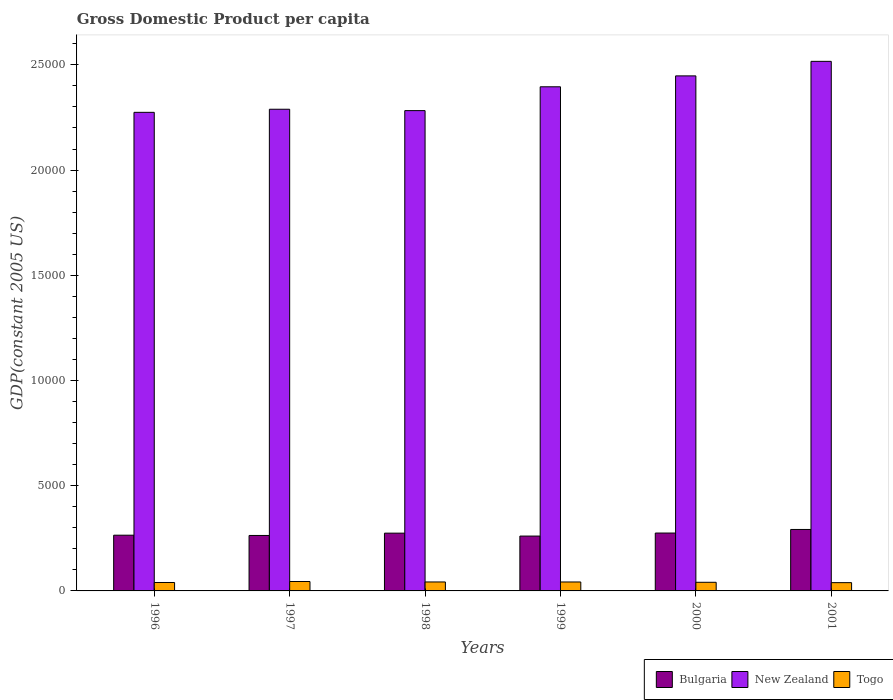How many different coloured bars are there?
Offer a very short reply. 3. How many groups of bars are there?
Give a very brief answer. 6. What is the label of the 3rd group of bars from the left?
Your answer should be compact. 1998. What is the GDP per capita in New Zealand in 1997?
Ensure brevity in your answer.  2.29e+04. Across all years, what is the maximum GDP per capita in New Zealand?
Offer a very short reply. 2.52e+04. Across all years, what is the minimum GDP per capita in New Zealand?
Ensure brevity in your answer.  2.27e+04. What is the total GDP per capita in Bulgaria in the graph?
Ensure brevity in your answer.  1.63e+04. What is the difference between the GDP per capita in Togo in 1996 and that in 2000?
Ensure brevity in your answer.  -9.59. What is the difference between the GDP per capita in Bulgaria in 1998 and the GDP per capita in Togo in 2001?
Make the answer very short. 2352.67. What is the average GDP per capita in Togo per year?
Your response must be concise. 417.01. In the year 2000, what is the difference between the GDP per capita in New Zealand and GDP per capita in Bulgaria?
Provide a short and direct response. 2.17e+04. What is the ratio of the GDP per capita in New Zealand in 1996 to that in 1999?
Offer a terse response. 0.95. Is the GDP per capita in New Zealand in 1998 less than that in 2001?
Provide a succinct answer. Yes. Is the difference between the GDP per capita in New Zealand in 1997 and 2000 greater than the difference between the GDP per capita in Bulgaria in 1997 and 2000?
Ensure brevity in your answer.  No. What is the difference between the highest and the second highest GDP per capita in Bulgaria?
Make the answer very short. 170.43. What is the difference between the highest and the lowest GDP per capita in Togo?
Provide a succinct answer. 53.78. What does the 1st bar from the right in 2001 represents?
Keep it short and to the point. Togo. How many years are there in the graph?
Make the answer very short. 6. Are the values on the major ticks of Y-axis written in scientific E-notation?
Your response must be concise. No. Does the graph contain any zero values?
Provide a short and direct response. No. Does the graph contain grids?
Give a very brief answer. No. Where does the legend appear in the graph?
Ensure brevity in your answer.  Bottom right. How many legend labels are there?
Offer a terse response. 3. How are the legend labels stacked?
Your response must be concise. Horizontal. What is the title of the graph?
Your answer should be compact. Gross Domestic Product per capita. Does "Burundi" appear as one of the legend labels in the graph?
Offer a very short reply. No. What is the label or title of the X-axis?
Make the answer very short. Years. What is the label or title of the Y-axis?
Keep it short and to the point. GDP(constant 2005 US). What is the GDP(constant 2005 US) of Bulgaria in 1996?
Keep it short and to the point. 2648.54. What is the GDP(constant 2005 US) of New Zealand in 1996?
Offer a terse response. 2.27e+04. What is the GDP(constant 2005 US) in Togo in 1996?
Your answer should be compact. 400.93. What is the GDP(constant 2005 US) in Bulgaria in 1997?
Provide a succinct answer. 2635.4. What is the GDP(constant 2005 US) of New Zealand in 1997?
Ensure brevity in your answer.  2.29e+04. What is the GDP(constant 2005 US) of Togo in 1997?
Make the answer very short. 447.02. What is the GDP(constant 2005 US) of Bulgaria in 1998?
Your answer should be compact. 2745.9. What is the GDP(constant 2005 US) in New Zealand in 1998?
Provide a succinct answer. 2.28e+04. What is the GDP(constant 2005 US) in Togo in 1998?
Provide a succinct answer. 425.56. What is the GDP(constant 2005 US) of Bulgaria in 1999?
Ensure brevity in your answer.  2606.43. What is the GDP(constant 2005 US) of New Zealand in 1999?
Offer a terse response. 2.40e+04. What is the GDP(constant 2005 US) of Togo in 1999?
Provide a succinct answer. 424.84. What is the GDP(constant 2005 US) of Bulgaria in 2000?
Make the answer very short. 2750.59. What is the GDP(constant 2005 US) in New Zealand in 2000?
Ensure brevity in your answer.  2.45e+04. What is the GDP(constant 2005 US) of Togo in 2000?
Provide a succinct answer. 410.52. What is the GDP(constant 2005 US) of Bulgaria in 2001?
Make the answer very short. 2921.02. What is the GDP(constant 2005 US) of New Zealand in 2001?
Ensure brevity in your answer.  2.52e+04. What is the GDP(constant 2005 US) in Togo in 2001?
Make the answer very short. 393.23. Across all years, what is the maximum GDP(constant 2005 US) in Bulgaria?
Offer a very short reply. 2921.02. Across all years, what is the maximum GDP(constant 2005 US) of New Zealand?
Provide a succinct answer. 2.52e+04. Across all years, what is the maximum GDP(constant 2005 US) in Togo?
Your answer should be very brief. 447.02. Across all years, what is the minimum GDP(constant 2005 US) in Bulgaria?
Your answer should be very brief. 2606.43. Across all years, what is the minimum GDP(constant 2005 US) of New Zealand?
Offer a terse response. 2.27e+04. Across all years, what is the minimum GDP(constant 2005 US) in Togo?
Make the answer very short. 393.23. What is the total GDP(constant 2005 US) of Bulgaria in the graph?
Keep it short and to the point. 1.63e+04. What is the total GDP(constant 2005 US) of New Zealand in the graph?
Offer a very short reply. 1.42e+05. What is the total GDP(constant 2005 US) in Togo in the graph?
Your answer should be very brief. 2502.09. What is the difference between the GDP(constant 2005 US) of Bulgaria in 1996 and that in 1997?
Your response must be concise. 13.14. What is the difference between the GDP(constant 2005 US) in New Zealand in 1996 and that in 1997?
Your answer should be very brief. -147.12. What is the difference between the GDP(constant 2005 US) in Togo in 1996 and that in 1997?
Your answer should be compact. -46.09. What is the difference between the GDP(constant 2005 US) of Bulgaria in 1996 and that in 1998?
Ensure brevity in your answer.  -97.36. What is the difference between the GDP(constant 2005 US) in New Zealand in 1996 and that in 1998?
Your answer should be compact. -81.64. What is the difference between the GDP(constant 2005 US) in Togo in 1996 and that in 1998?
Your answer should be very brief. -24.63. What is the difference between the GDP(constant 2005 US) of Bulgaria in 1996 and that in 1999?
Make the answer very short. 42.11. What is the difference between the GDP(constant 2005 US) in New Zealand in 1996 and that in 1999?
Provide a short and direct response. -1214.37. What is the difference between the GDP(constant 2005 US) in Togo in 1996 and that in 1999?
Offer a terse response. -23.91. What is the difference between the GDP(constant 2005 US) of Bulgaria in 1996 and that in 2000?
Your response must be concise. -102.05. What is the difference between the GDP(constant 2005 US) of New Zealand in 1996 and that in 2000?
Your answer should be compact. -1732.25. What is the difference between the GDP(constant 2005 US) of Togo in 1996 and that in 2000?
Make the answer very short. -9.59. What is the difference between the GDP(constant 2005 US) of Bulgaria in 1996 and that in 2001?
Your answer should be very brief. -272.48. What is the difference between the GDP(constant 2005 US) in New Zealand in 1996 and that in 2001?
Your answer should be very brief. -2422.9. What is the difference between the GDP(constant 2005 US) in Togo in 1996 and that in 2001?
Your answer should be compact. 7.69. What is the difference between the GDP(constant 2005 US) of Bulgaria in 1997 and that in 1998?
Keep it short and to the point. -110.5. What is the difference between the GDP(constant 2005 US) of New Zealand in 1997 and that in 1998?
Offer a terse response. 65.48. What is the difference between the GDP(constant 2005 US) in Togo in 1997 and that in 1998?
Offer a very short reply. 21.46. What is the difference between the GDP(constant 2005 US) of Bulgaria in 1997 and that in 1999?
Ensure brevity in your answer.  28.97. What is the difference between the GDP(constant 2005 US) of New Zealand in 1997 and that in 1999?
Give a very brief answer. -1067.25. What is the difference between the GDP(constant 2005 US) of Togo in 1997 and that in 1999?
Your answer should be very brief. 22.18. What is the difference between the GDP(constant 2005 US) in Bulgaria in 1997 and that in 2000?
Keep it short and to the point. -115.19. What is the difference between the GDP(constant 2005 US) of New Zealand in 1997 and that in 2000?
Provide a succinct answer. -1585.13. What is the difference between the GDP(constant 2005 US) of Togo in 1997 and that in 2000?
Offer a very short reply. 36.5. What is the difference between the GDP(constant 2005 US) in Bulgaria in 1997 and that in 2001?
Provide a short and direct response. -285.62. What is the difference between the GDP(constant 2005 US) of New Zealand in 1997 and that in 2001?
Your response must be concise. -2275.78. What is the difference between the GDP(constant 2005 US) in Togo in 1997 and that in 2001?
Offer a very short reply. 53.78. What is the difference between the GDP(constant 2005 US) of Bulgaria in 1998 and that in 1999?
Provide a succinct answer. 139.47. What is the difference between the GDP(constant 2005 US) in New Zealand in 1998 and that in 1999?
Your answer should be compact. -1132.73. What is the difference between the GDP(constant 2005 US) of Togo in 1998 and that in 1999?
Give a very brief answer. 0.72. What is the difference between the GDP(constant 2005 US) of Bulgaria in 1998 and that in 2000?
Give a very brief answer. -4.69. What is the difference between the GDP(constant 2005 US) of New Zealand in 1998 and that in 2000?
Give a very brief answer. -1650.62. What is the difference between the GDP(constant 2005 US) in Togo in 1998 and that in 2000?
Your response must be concise. 15.04. What is the difference between the GDP(constant 2005 US) in Bulgaria in 1998 and that in 2001?
Keep it short and to the point. -175.12. What is the difference between the GDP(constant 2005 US) of New Zealand in 1998 and that in 2001?
Provide a succinct answer. -2341.26. What is the difference between the GDP(constant 2005 US) in Togo in 1998 and that in 2001?
Make the answer very short. 32.32. What is the difference between the GDP(constant 2005 US) in Bulgaria in 1999 and that in 2000?
Offer a terse response. -144.16. What is the difference between the GDP(constant 2005 US) in New Zealand in 1999 and that in 2000?
Your answer should be very brief. -517.89. What is the difference between the GDP(constant 2005 US) of Togo in 1999 and that in 2000?
Keep it short and to the point. 14.32. What is the difference between the GDP(constant 2005 US) in Bulgaria in 1999 and that in 2001?
Keep it short and to the point. -314.59. What is the difference between the GDP(constant 2005 US) of New Zealand in 1999 and that in 2001?
Provide a short and direct response. -1208.53. What is the difference between the GDP(constant 2005 US) of Togo in 1999 and that in 2001?
Give a very brief answer. 31.6. What is the difference between the GDP(constant 2005 US) in Bulgaria in 2000 and that in 2001?
Your answer should be very brief. -170.43. What is the difference between the GDP(constant 2005 US) of New Zealand in 2000 and that in 2001?
Your answer should be compact. -690.64. What is the difference between the GDP(constant 2005 US) of Togo in 2000 and that in 2001?
Provide a succinct answer. 17.29. What is the difference between the GDP(constant 2005 US) of Bulgaria in 1996 and the GDP(constant 2005 US) of New Zealand in 1997?
Ensure brevity in your answer.  -2.02e+04. What is the difference between the GDP(constant 2005 US) of Bulgaria in 1996 and the GDP(constant 2005 US) of Togo in 1997?
Your answer should be very brief. 2201.52. What is the difference between the GDP(constant 2005 US) in New Zealand in 1996 and the GDP(constant 2005 US) in Togo in 1997?
Provide a succinct answer. 2.23e+04. What is the difference between the GDP(constant 2005 US) of Bulgaria in 1996 and the GDP(constant 2005 US) of New Zealand in 1998?
Offer a very short reply. -2.02e+04. What is the difference between the GDP(constant 2005 US) of Bulgaria in 1996 and the GDP(constant 2005 US) of Togo in 1998?
Provide a short and direct response. 2222.98. What is the difference between the GDP(constant 2005 US) in New Zealand in 1996 and the GDP(constant 2005 US) in Togo in 1998?
Offer a very short reply. 2.23e+04. What is the difference between the GDP(constant 2005 US) in Bulgaria in 1996 and the GDP(constant 2005 US) in New Zealand in 1999?
Ensure brevity in your answer.  -2.13e+04. What is the difference between the GDP(constant 2005 US) in Bulgaria in 1996 and the GDP(constant 2005 US) in Togo in 1999?
Your answer should be compact. 2223.7. What is the difference between the GDP(constant 2005 US) of New Zealand in 1996 and the GDP(constant 2005 US) of Togo in 1999?
Provide a short and direct response. 2.23e+04. What is the difference between the GDP(constant 2005 US) in Bulgaria in 1996 and the GDP(constant 2005 US) in New Zealand in 2000?
Keep it short and to the point. -2.18e+04. What is the difference between the GDP(constant 2005 US) in Bulgaria in 1996 and the GDP(constant 2005 US) in Togo in 2000?
Keep it short and to the point. 2238.02. What is the difference between the GDP(constant 2005 US) in New Zealand in 1996 and the GDP(constant 2005 US) in Togo in 2000?
Give a very brief answer. 2.23e+04. What is the difference between the GDP(constant 2005 US) of Bulgaria in 1996 and the GDP(constant 2005 US) of New Zealand in 2001?
Offer a terse response. -2.25e+04. What is the difference between the GDP(constant 2005 US) in Bulgaria in 1996 and the GDP(constant 2005 US) in Togo in 2001?
Your response must be concise. 2255.3. What is the difference between the GDP(constant 2005 US) in New Zealand in 1996 and the GDP(constant 2005 US) in Togo in 2001?
Offer a very short reply. 2.24e+04. What is the difference between the GDP(constant 2005 US) in Bulgaria in 1997 and the GDP(constant 2005 US) in New Zealand in 1998?
Ensure brevity in your answer.  -2.02e+04. What is the difference between the GDP(constant 2005 US) of Bulgaria in 1997 and the GDP(constant 2005 US) of Togo in 1998?
Keep it short and to the point. 2209.84. What is the difference between the GDP(constant 2005 US) of New Zealand in 1997 and the GDP(constant 2005 US) of Togo in 1998?
Your answer should be very brief. 2.25e+04. What is the difference between the GDP(constant 2005 US) in Bulgaria in 1997 and the GDP(constant 2005 US) in New Zealand in 1999?
Offer a terse response. -2.13e+04. What is the difference between the GDP(constant 2005 US) in Bulgaria in 1997 and the GDP(constant 2005 US) in Togo in 1999?
Offer a very short reply. 2210.56. What is the difference between the GDP(constant 2005 US) of New Zealand in 1997 and the GDP(constant 2005 US) of Togo in 1999?
Your response must be concise. 2.25e+04. What is the difference between the GDP(constant 2005 US) in Bulgaria in 1997 and the GDP(constant 2005 US) in New Zealand in 2000?
Provide a short and direct response. -2.18e+04. What is the difference between the GDP(constant 2005 US) of Bulgaria in 1997 and the GDP(constant 2005 US) of Togo in 2000?
Offer a terse response. 2224.88. What is the difference between the GDP(constant 2005 US) in New Zealand in 1997 and the GDP(constant 2005 US) in Togo in 2000?
Provide a succinct answer. 2.25e+04. What is the difference between the GDP(constant 2005 US) in Bulgaria in 1997 and the GDP(constant 2005 US) in New Zealand in 2001?
Keep it short and to the point. -2.25e+04. What is the difference between the GDP(constant 2005 US) of Bulgaria in 1997 and the GDP(constant 2005 US) of Togo in 2001?
Your answer should be compact. 2242.17. What is the difference between the GDP(constant 2005 US) in New Zealand in 1997 and the GDP(constant 2005 US) in Togo in 2001?
Offer a very short reply. 2.25e+04. What is the difference between the GDP(constant 2005 US) in Bulgaria in 1998 and the GDP(constant 2005 US) in New Zealand in 1999?
Offer a terse response. -2.12e+04. What is the difference between the GDP(constant 2005 US) of Bulgaria in 1998 and the GDP(constant 2005 US) of Togo in 1999?
Offer a terse response. 2321.07. What is the difference between the GDP(constant 2005 US) in New Zealand in 1998 and the GDP(constant 2005 US) in Togo in 1999?
Offer a very short reply. 2.24e+04. What is the difference between the GDP(constant 2005 US) of Bulgaria in 1998 and the GDP(constant 2005 US) of New Zealand in 2000?
Keep it short and to the point. -2.17e+04. What is the difference between the GDP(constant 2005 US) of Bulgaria in 1998 and the GDP(constant 2005 US) of Togo in 2000?
Ensure brevity in your answer.  2335.38. What is the difference between the GDP(constant 2005 US) of New Zealand in 1998 and the GDP(constant 2005 US) of Togo in 2000?
Offer a terse response. 2.24e+04. What is the difference between the GDP(constant 2005 US) of Bulgaria in 1998 and the GDP(constant 2005 US) of New Zealand in 2001?
Offer a terse response. -2.24e+04. What is the difference between the GDP(constant 2005 US) in Bulgaria in 1998 and the GDP(constant 2005 US) in Togo in 2001?
Make the answer very short. 2352.67. What is the difference between the GDP(constant 2005 US) in New Zealand in 1998 and the GDP(constant 2005 US) in Togo in 2001?
Provide a succinct answer. 2.24e+04. What is the difference between the GDP(constant 2005 US) of Bulgaria in 1999 and the GDP(constant 2005 US) of New Zealand in 2000?
Your answer should be very brief. -2.19e+04. What is the difference between the GDP(constant 2005 US) of Bulgaria in 1999 and the GDP(constant 2005 US) of Togo in 2000?
Give a very brief answer. 2195.91. What is the difference between the GDP(constant 2005 US) of New Zealand in 1999 and the GDP(constant 2005 US) of Togo in 2000?
Keep it short and to the point. 2.35e+04. What is the difference between the GDP(constant 2005 US) in Bulgaria in 1999 and the GDP(constant 2005 US) in New Zealand in 2001?
Your answer should be compact. -2.26e+04. What is the difference between the GDP(constant 2005 US) of Bulgaria in 1999 and the GDP(constant 2005 US) of Togo in 2001?
Provide a succinct answer. 2213.19. What is the difference between the GDP(constant 2005 US) in New Zealand in 1999 and the GDP(constant 2005 US) in Togo in 2001?
Provide a succinct answer. 2.36e+04. What is the difference between the GDP(constant 2005 US) of Bulgaria in 2000 and the GDP(constant 2005 US) of New Zealand in 2001?
Ensure brevity in your answer.  -2.24e+04. What is the difference between the GDP(constant 2005 US) in Bulgaria in 2000 and the GDP(constant 2005 US) in Togo in 2001?
Provide a succinct answer. 2357.35. What is the difference between the GDP(constant 2005 US) in New Zealand in 2000 and the GDP(constant 2005 US) in Togo in 2001?
Your answer should be compact. 2.41e+04. What is the average GDP(constant 2005 US) of Bulgaria per year?
Your answer should be very brief. 2717.98. What is the average GDP(constant 2005 US) of New Zealand per year?
Your answer should be compact. 2.37e+04. What is the average GDP(constant 2005 US) of Togo per year?
Offer a very short reply. 417.01. In the year 1996, what is the difference between the GDP(constant 2005 US) in Bulgaria and GDP(constant 2005 US) in New Zealand?
Provide a succinct answer. -2.01e+04. In the year 1996, what is the difference between the GDP(constant 2005 US) in Bulgaria and GDP(constant 2005 US) in Togo?
Your answer should be compact. 2247.61. In the year 1996, what is the difference between the GDP(constant 2005 US) in New Zealand and GDP(constant 2005 US) in Togo?
Offer a terse response. 2.23e+04. In the year 1997, what is the difference between the GDP(constant 2005 US) of Bulgaria and GDP(constant 2005 US) of New Zealand?
Provide a short and direct response. -2.03e+04. In the year 1997, what is the difference between the GDP(constant 2005 US) of Bulgaria and GDP(constant 2005 US) of Togo?
Your response must be concise. 2188.38. In the year 1997, what is the difference between the GDP(constant 2005 US) in New Zealand and GDP(constant 2005 US) in Togo?
Ensure brevity in your answer.  2.24e+04. In the year 1998, what is the difference between the GDP(constant 2005 US) of Bulgaria and GDP(constant 2005 US) of New Zealand?
Offer a terse response. -2.01e+04. In the year 1998, what is the difference between the GDP(constant 2005 US) in Bulgaria and GDP(constant 2005 US) in Togo?
Your answer should be very brief. 2320.34. In the year 1998, what is the difference between the GDP(constant 2005 US) of New Zealand and GDP(constant 2005 US) of Togo?
Your answer should be very brief. 2.24e+04. In the year 1999, what is the difference between the GDP(constant 2005 US) of Bulgaria and GDP(constant 2005 US) of New Zealand?
Your answer should be compact. -2.14e+04. In the year 1999, what is the difference between the GDP(constant 2005 US) of Bulgaria and GDP(constant 2005 US) of Togo?
Offer a very short reply. 2181.59. In the year 1999, what is the difference between the GDP(constant 2005 US) of New Zealand and GDP(constant 2005 US) of Togo?
Your response must be concise. 2.35e+04. In the year 2000, what is the difference between the GDP(constant 2005 US) of Bulgaria and GDP(constant 2005 US) of New Zealand?
Provide a short and direct response. -2.17e+04. In the year 2000, what is the difference between the GDP(constant 2005 US) in Bulgaria and GDP(constant 2005 US) in Togo?
Give a very brief answer. 2340.07. In the year 2000, what is the difference between the GDP(constant 2005 US) in New Zealand and GDP(constant 2005 US) in Togo?
Keep it short and to the point. 2.41e+04. In the year 2001, what is the difference between the GDP(constant 2005 US) of Bulgaria and GDP(constant 2005 US) of New Zealand?
Offer a terse response. -2.22e+04. In the year 2001, what is the difference between the GDP(constant 2005 US) of Bulgaria and GDP(constant 2005 US) of Togo?
Provide a succinct answer. 2527.79. In the year 2001, what is the difference between the GDP(constant 2005 US) in New Zealand and GDP(constant 2005 US) in Togo?
Your response must be concise. 2.48e+04. What is the ratio of the GDP(constant 2005 US) of Togo in 1996 to that in 1997?
Your response must be concise. 0.9. What is the ratio of the GDP(constant 2005 US) of Bulgaria in 1996 to that in 1998?
Offer a very short reply. 0.96. What is the ratio of the GDP(constant 2005 US) in New Zealand in 1996 to that in 1998?
Offer a terse response. 1. What is the ratio of the GDP(constant 2005 US) of Togo in 1996 to that in 1998?
Offer a very short reply. 0.94. What is the ratio of the GDP(constant 2005 US) in Bulgaria in 1996 to that in 1999?
Make the answer very short. 1.02. What is the ratio of the GDP(constant 2005 US) of New Zealand in 1996 to that in 1999?
Ensure brevity in your answer.  0.95. What is the ratio of the GDP(constant 2005 US) in Togo in 1996 to that in 1999?
Offer a terse response. 0.94. What is the ratio of the GDP(constant 2005 US) in Bulgaria in 1996 to that in 2000?
Your answer should be very brief. 0.96. What is the ratio of the GDP(constant 2005 US) in New Zealand in 1996 to that in 2000?
Your response must be concise. 0.93. What is the ratio of the GDP(constant 2005 US) of Togo in 1996 to that in 2000?
Make the answer very short. 0.98. What is the ratio of the GDP(constant 2005 US) in Bulgaria in 1996 to that in 2001?
Your answer should be very brief. 0.91. What is the ratio of the GDP(constant 2005 US) in New Zealand in 1996 to that in 2001?
Provide a short and direct response. 0.9. What is the ratio of the GDP(constant 2005 US) of Togo in 1996 to that in 2001?
Ensure brevity in your answer.  1.02. What is the ratio of the GDP(constant 2005 US) in Bulgaria in 1997 to that in 1998?
Provide a short and direct response. 0.96. What is the ratio of the GDP(constant 2005 US) in Togo in 1997 to that in 1998?
Your response must be concise. 1.05. What is the ratio of the GDP(constant 2005 US) in Bulgaria in 1997 to that in 1999?
Provide a succinct answer. 1.01. What is the ratio of the GDP(constant 2005 US) in New Zealand in 1997 to that in 1999?
Give a very brief answer. 0.96. What is the ratio of the GDP(constant 2005 US) in Togo in 1997 to that in 1999?
Your answer should be compact. 1.05. What is the ratio of the GDP(constant 2005 US) of Bulgaria in 1997 to that in 2000?
Your answer should be very brief. 0.96. What is the ratio of the GDP(constant 2005 US) of New Zealand in 1997 to that in 2000?
Keep it short and to the point. 0.94. What is the ratio of the GDP(constant 2005 US) in Togo in 1997 to that in 2000?
Offer a terse response. 1.09. What is the ratio of the GDP(constant 2005 US) in Bulgaria in 1997 to that in 2001?
Provide a short and direct response. 0.9. What is the ratio of the GDP(constant 2005 US) in New Zealand in 1997 to that in 2001?
Ensure brevity in your answer.  0.91. What is the ratio of the GDP(constant 2005 US) in Togo in 1997 to that in 2001?
Ensure brevity in your answer.  1.14. What is the ratio of the GDP(constant 2005 US) of Bulgaria in 1998 to that in 1999?
Give a very brief answer. 1.05. What is the ratio of the GDP(constant 2005 US) of New Zealand in 1998 to that in 1999?
Offer a very short reply. 0.95. What is the ratio of the GDP(constant 2005 US) in New Zealand in 1998 to that in 2000?
Keep it short and to the point. 0.93. What is the ratio of the GDP(constant 2005 US) of Togo in 1998 to that in 2000?
Provide a short and direct response. 1.04. What is the ratio of the GDP(constant 2005 US) in Bulgaria in 1998 to that in 2001?
Ensure brevity in your answer.  0.94. What is the ratio of the GDP(constant 2005 US) in New Zealand in 1998 to that in 2001?
Offer a terse response. 0.91. What is the ratio of the GDP(constant 2005 US) in Togo in 1998 to that in 2001?
Provide a succinct answer. 1.08. What is the ratio of the GDP(constant 2005 US) of Bulgaria in 1999 to that in 2000?
Provide a short and direct response. 0.95. What is the ratio of the GDP(constant 2005 US) of New Zealand in 1999 to that in 2000?
Keep it short and to the point. 0.98. What is the ratio of the GDP(constant 2005 US) in Togo in 1999 to that in 2000?
Your answer should be very brief. 1.03. What is the ratio of the GDP(constant 2005 US) in Bulgaria in 1999 to that in 2001?
Your answer should be compact. 0.89. What is the ratio of the GDP(constant 2005 US) in New Zealand in 1999 to that in 2001?
Provide a succinct answer. 0.95. What is the ratio of the GDP(constant 2005 US) in Togo in 1999 to that in 2001?
Your answer should be very brief. 1.08. What is the ratio of the GDP(constant 2005 US) in Bulgaria in 2000 to that in 2001?
Give a very brief answer. 0.94. What is the ratio of the GDP(constant 2005 US) in New Zealand in 2000 to that in 2001?
Keep it short and to the point. 0.97. What is the ratio of the GDP(constant 2005 US) in Togo in 2000 to that in 2001?
Make the answer very short. 1.04. What is the difference between the highest and the second highest GDP(constant 2005 US) of Bulgaria?
Offer a terse response. 170.43. What is the difference between the highest and the second highest GDP(constant 2005 US) in New Zealand?
Give a very brief answer. 690.64. What is the difference between the highest and the second highest GDP(constant 2005 US) of Togo?
Your answer should be very brief. 21.46. What is the difference between the highest and the lowest GDP(constant 2005 US) of Bulgaria?
Make the answer very short. 314.59. What is the difference between the highest and the lowest GDP(constant 2005 US) in New Zealand?
Give a very brief answer. 2422.9. What is the difference between the highest and the lowest GDP(constant 2005 US) in Togo?
Keep it short and to the point. 53.78. 